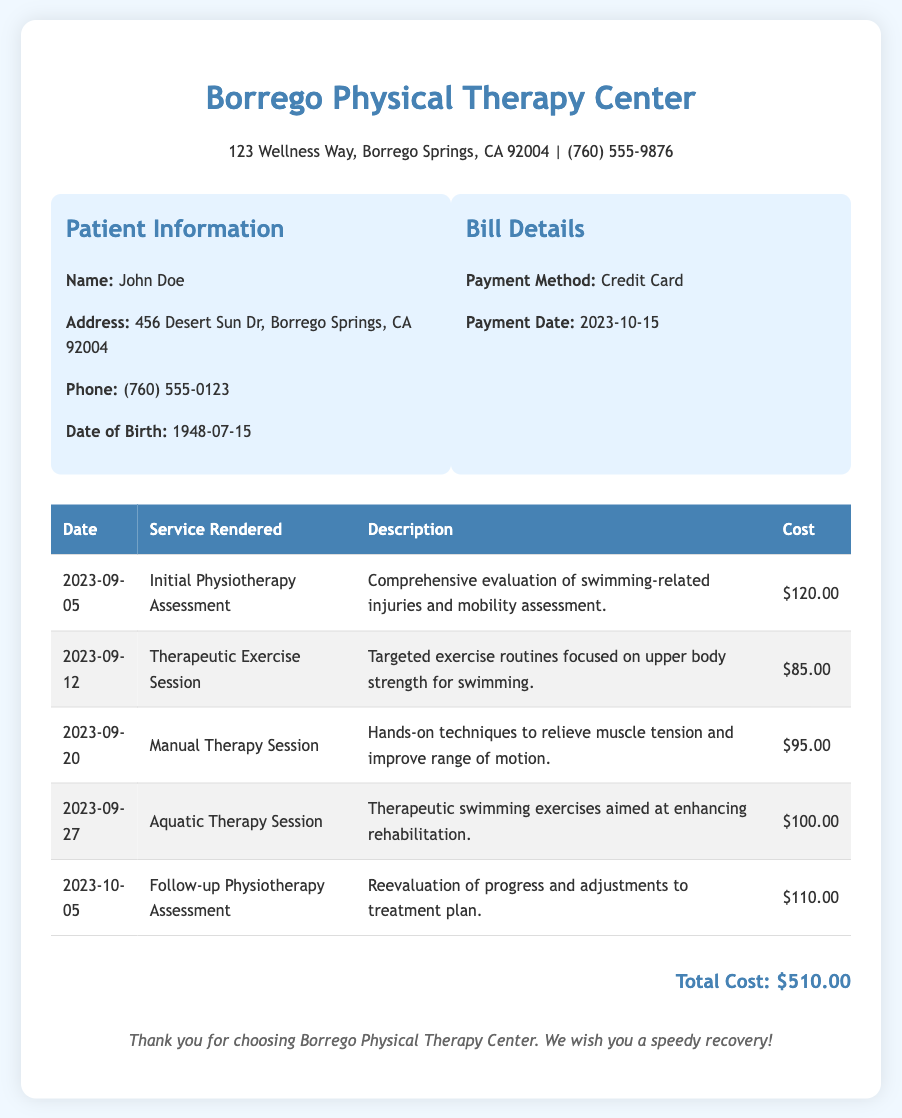what is the name of the patient? The patient's name is provided in the document under Patient Information as John Doe.
Answer: John Doe what is the total cost of the physiotherapy services? The total cost is displayed at the bottom of the bill, summing the individual costs of all services rendered, which is $510.00.
Answer: $510.00 what was the date of the initial physiotherapy assessment? The date can be found in the first entry of the services table, indicating the session took place on September 5, 2023.
Answer: 2023-09-05 how much was charged for the aquatic therapy session? The cost for the aquatic therapy session can be found in the services table under the corresponding date, which indicates a fee of $100.00.
Answer: $100.00 how many therapy sessions are listed in the document? By counting the rows in the services table, the total number of therapy sessions listed is five.
Answer: 5 what type of payment was used for the bill? The document specifies the payment method in the Bill Details section as being made via credit card.
Answer: Credit Card which service involved hands-on techniques? The document describes the Manual Therapy Session as the one involving hands-on techniques, found in the services table.
Answer: Manual Therapy Session what is the address of Borrego Physical Therapy Center? The address is displayed at the top of the document, indicating the facility is located at 123 Wellness Way, Borrego Springs, CA 92004.
Answer: 123 Wellness Way, Borrego Springs, CA 92004 when was the follow-up physiotherapy assessment scheduled? The date for the follow-up assessment is listed in the services table, occurring on October 5, 2023.
Answer: 2023-10-05 